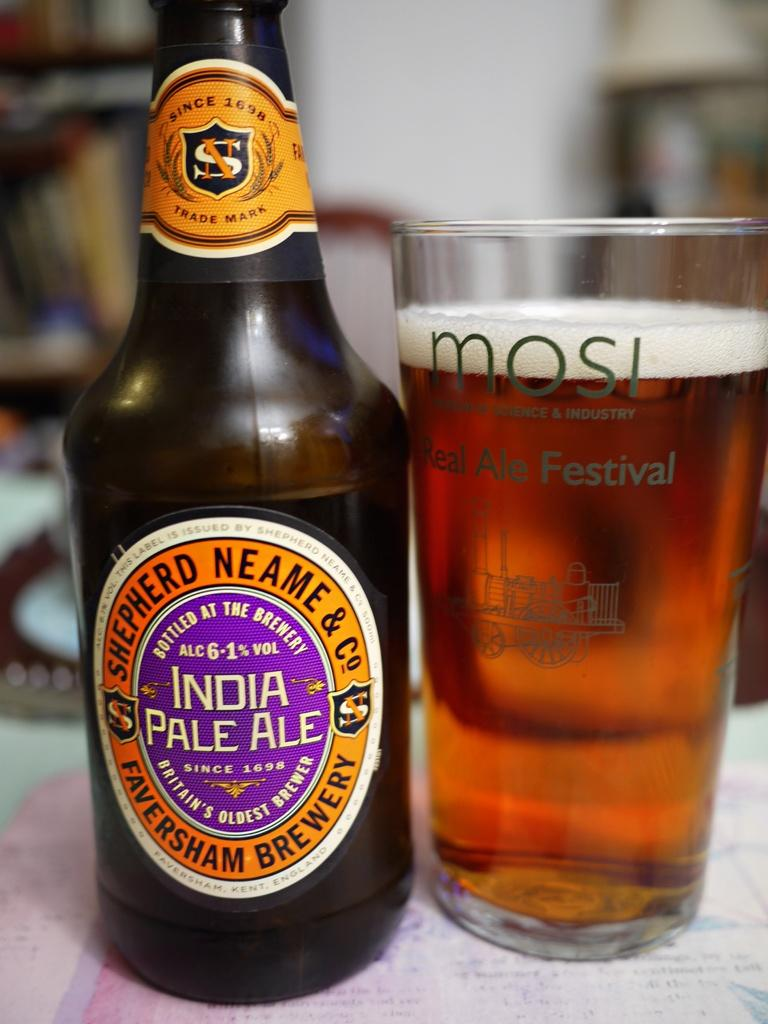<image>
Offer a succinct explanation of the picture presented. A bottle of India Pale Ale next to a glass of beer. 